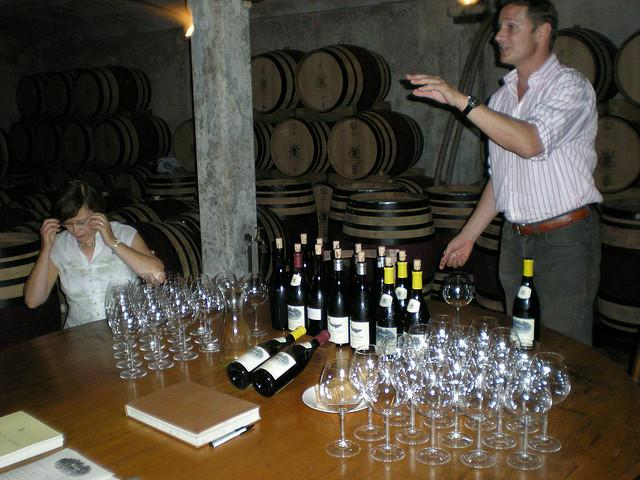What kind of wood is used to make the barrels in the background? oak 